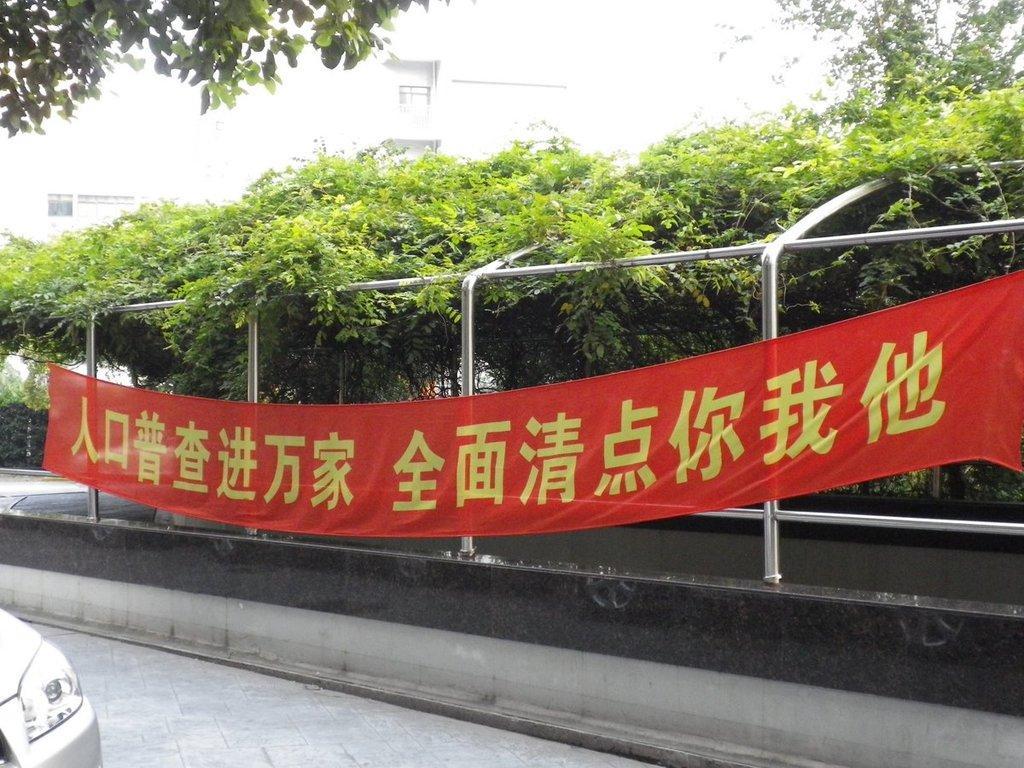In one or two sentences, can you explain what this image depicts? In this image there is a car on a road, beside the road there is fencing to that fencing there is a banner on that banner there is some text, in the background there are trees. 